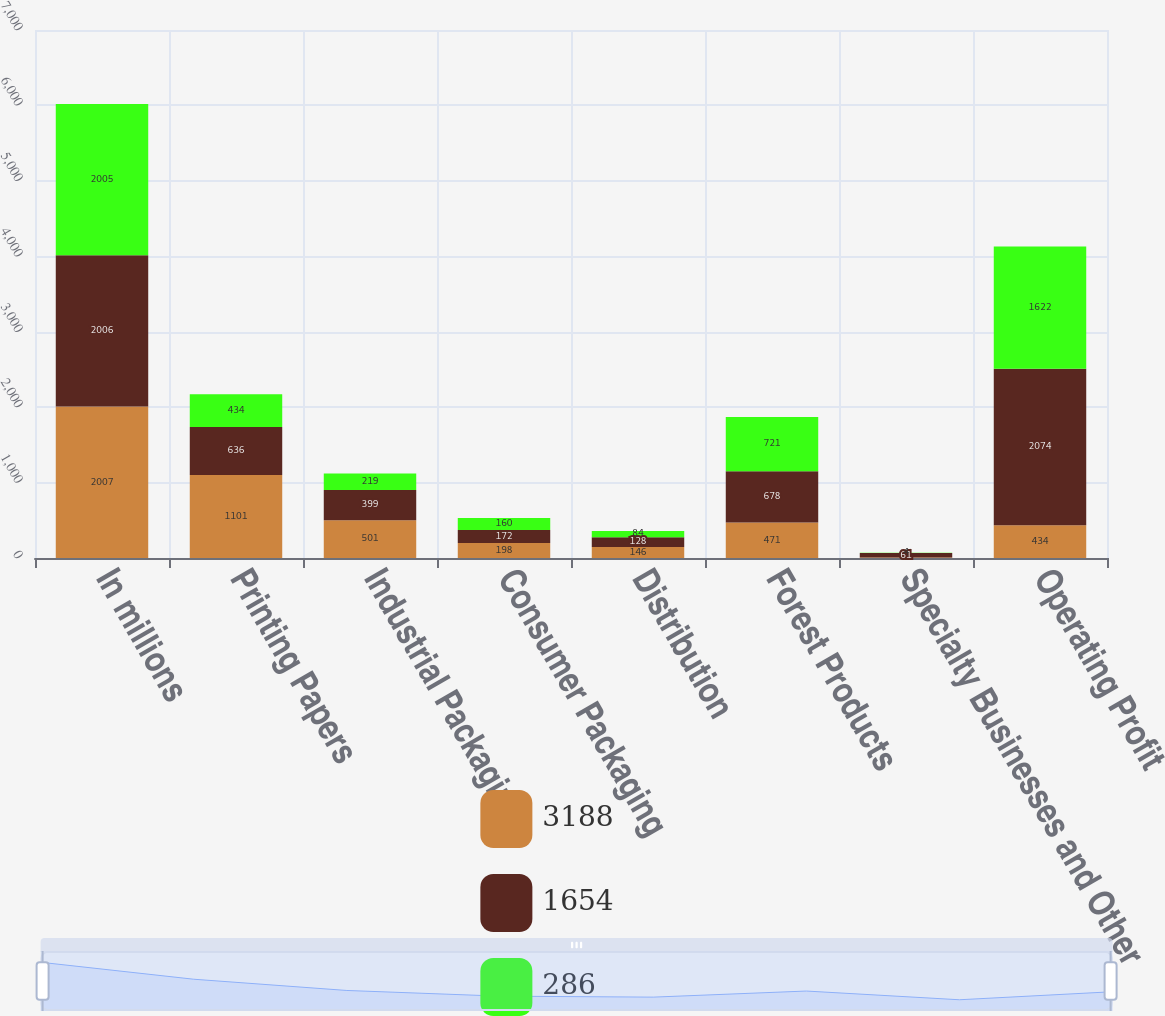<chart> <loc_0><loc_0><loc_500><loc_500><stacked_bar_chart><ecel><fcel>In millions<fcel>Printing Papers<fcel>Industrial Packaging<fcel>Consumer Packaging<fcel>Distribution<fcel>Forest Products<fcel>Specialty Businesses and Other<fcel>Operating Profit<nl><fcel>3188<fcel>2007<fcel>1101<fcel>501<fcel>198<fcel>146<fcel>471<fcel>6<fcel>434<nl><fcel>1654<fcel>2006<fcel>636<fcel>399<fcel>172<fcel>128<fcel>678<fcel>61<fcel>2074<nl><fcel>286<fcel>2005<fcel>434<fcel>219<fcel>160<fcel>84<fcel>721<fcel>4<fcel>1622<nl></chart> 